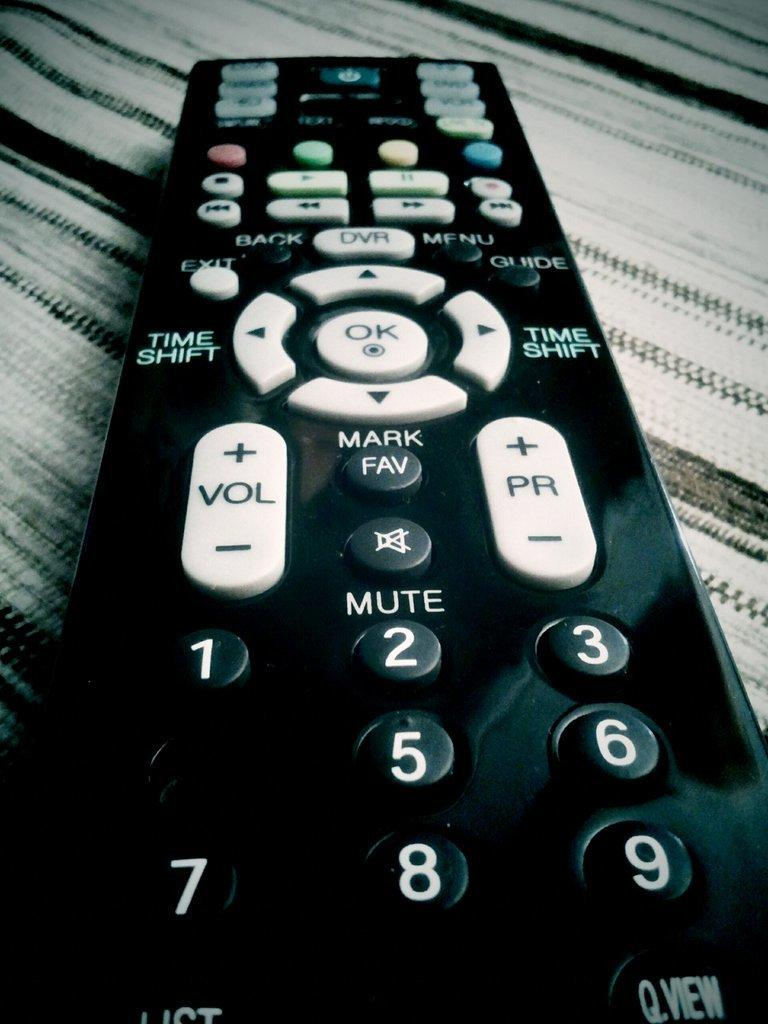<image>
Summarize the visual content of the image. A black television remote has the mute button in between the volume and channel controls. 